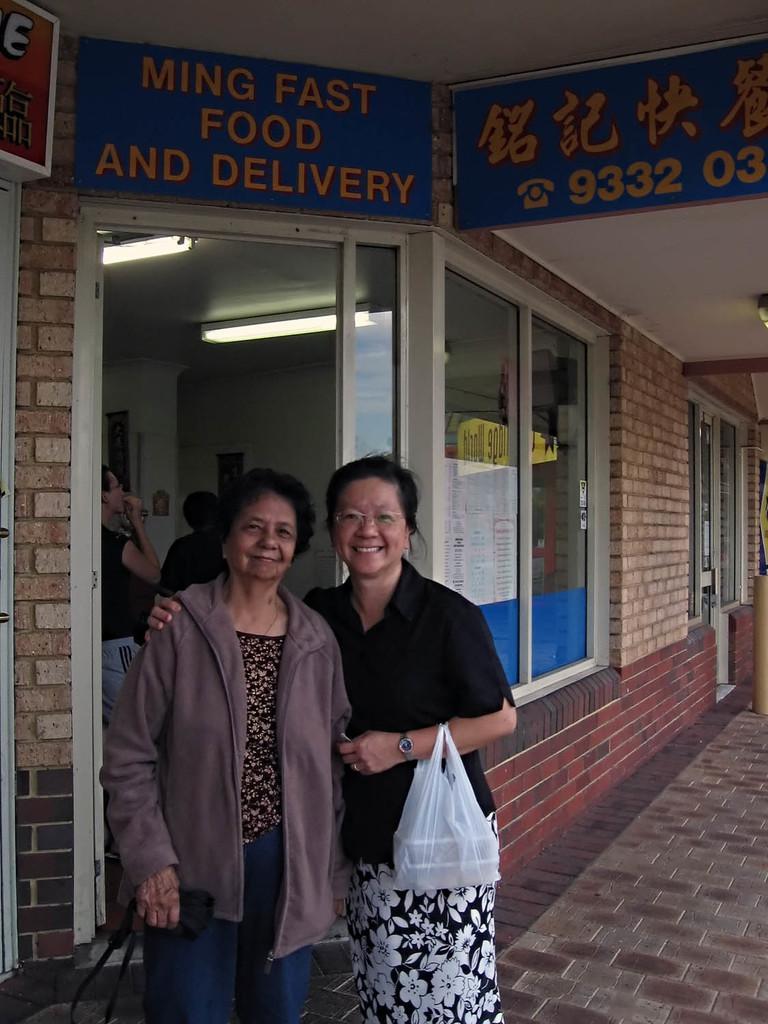How would you summarize this image in a sentence or two? Women are standing holding covers, this is a building with the windows, that are boards. 